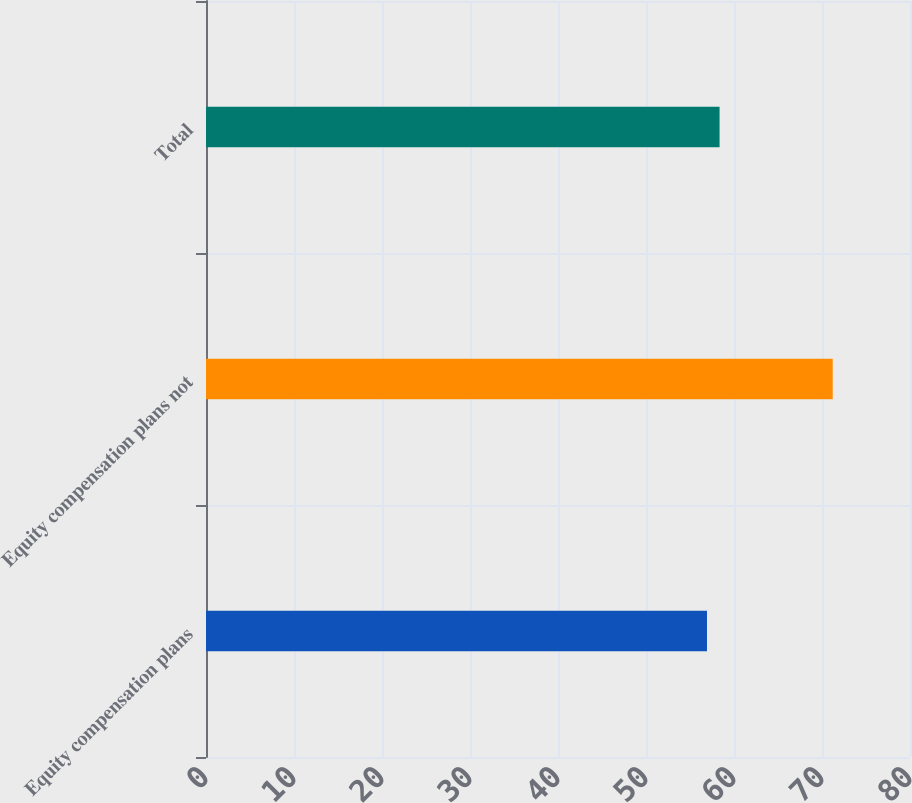<chart> <loc_0><loc_0><loc_500><loc_500><bar_chart><fcel>Equity compensation plans<fcel>Equity compensation plans not<fcel>Total<nl><fcel>56.93<fcel>71.22<fcel>58.36<nl></chart> 